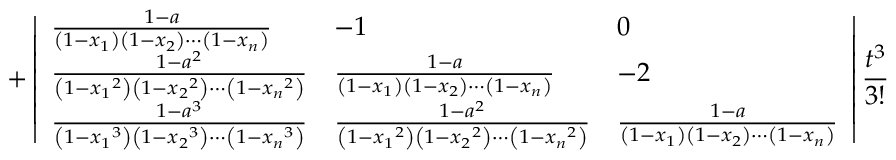Convert formula to latex. <formula><loc_0><loc_0><loc_500><loc_500>+ \left | \begin{array} { l l l } { \frac { 1 - a } { \left ( 1 - { x _ { 1 } } \right ) \left ( 1 - { x _ { 2 } } \right ) \cdots \left ( 1 - { x _ { n } } \right ) } } & { - 1 } & { 0 } \\ { \frac { 1 - a ^ { 2 } } { \left ( 1 - { x _ { 1 } } ^ { 2 } \right ) \left ( 1 - { x _ { 2 } } ^ { 2 } \right ) \cdots \left ( 1 - { x _ { n } } ^ { 2 } \right ) } } & { \frac { 1 - a } { \left ( 1 - { x _ { 1 } } \right ) \left ( 1 - { x _ { 2 } } \right ) \cdots \left ( 1 - { x _ { n } } \right ) } } & { - 2 } \\ { \frac { 1 - a ^ { 3 } } { \left ( 1 - { x _ { 1 } } ^ { 3 } \right ) \left ( 1 - { x _ { 2 } } ^ { 3 } \right ) \cdots \left ( 1 - { x _ { n } } ^ { 3 } \right ) } } & { \frac { 1 - a ^ { 2 } } { \left ( 1 - { x _ { 1 } } ^ { 2 } \right ) \left ( 1 - { x _ { 2 } } ^ { 2 } \right ) \cdots \left ( 1 - { x _ { n } } ^ { 2 } \right ) } } & { \frac { 1 - a } { \left ( 1 - { x _ { 1 } } \right ) \left ( 1 - { x _ { 2 } } \right ) \cdots \left ( 1 - { x _ { n } } \right ) } } \end{array} \right | \frac { t ^ { 3 } } { 3 ! }</formula> 